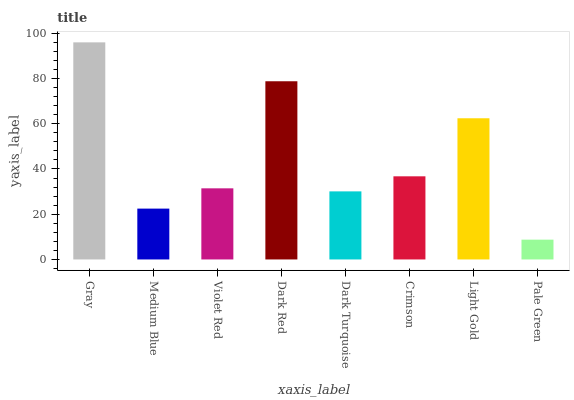Is Pale Green the minimum?
Answer yes or no. Yes. Is Gray the maximum?
Answer yes or no. Yes. Is Medium Blue the minimum?
Answer yes or no. No. Is Medium Blue the maximum?
Answer yes or no. No. Is Gray greater than Medium Blue?
Answer yes or no. Yes. Is Medium Blue less than Gray?
Answer yes or no. Yes. Is Medium Blue greater than Gray?
Answer yes or no. No. Is Gray less than Medium Blue?
Answer yes or no. No. Is Crimson the high median?
Answer yes or no. Yes. Is Violet Red the low median?
Answer yes or no. Yes. Is Medium Blue the high median?
Answer yes or no. No. Is Pale Green the low median?
Answer yes or no. No. 